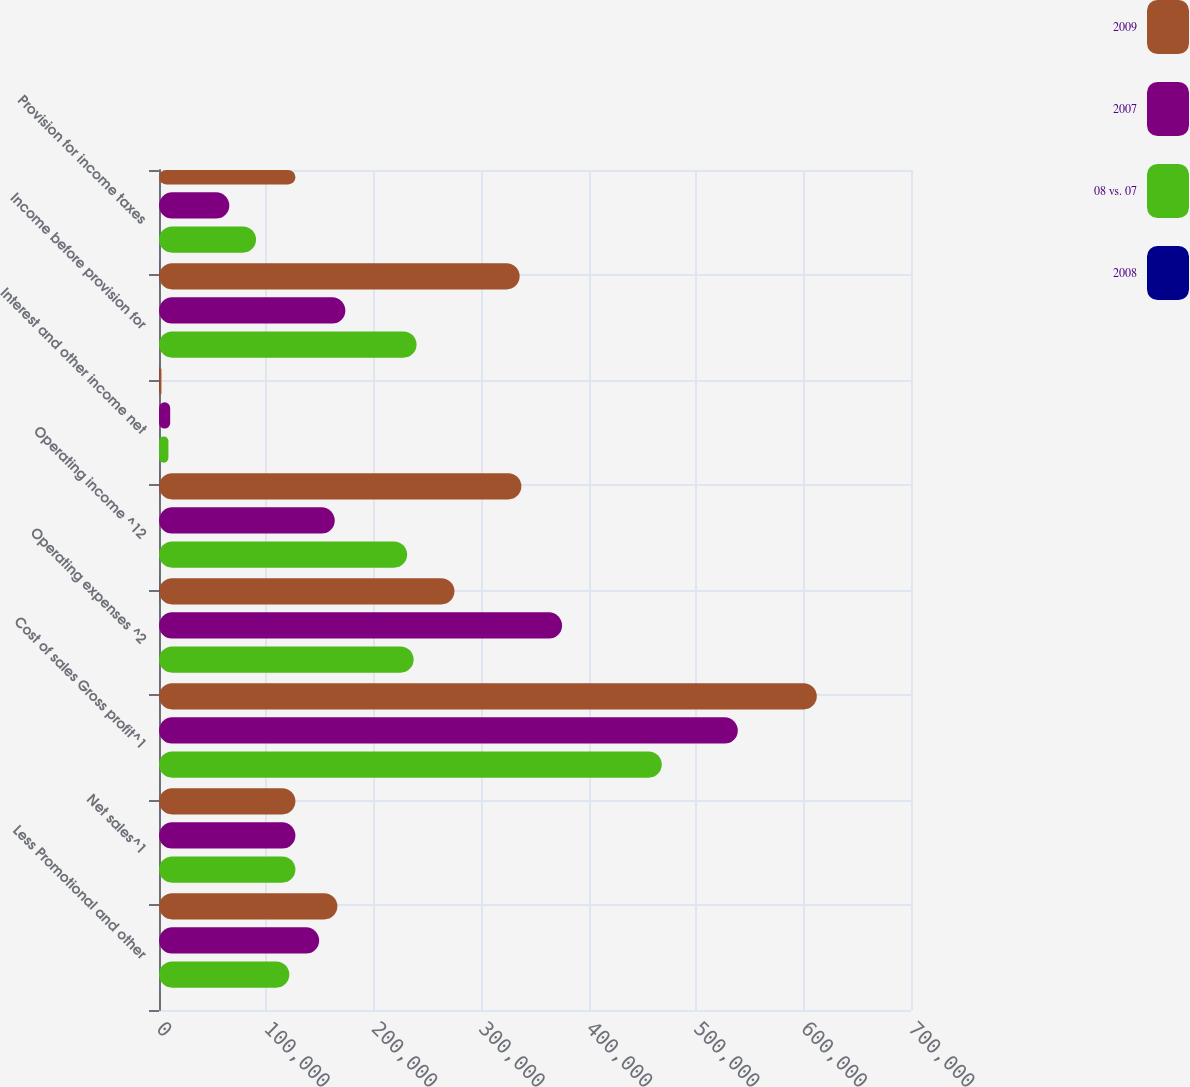Convert chart. <chart><loc_0><loc_0><loc_500><loc_500><stacked_bar_chart><ecel><fcel>Less Promotional and other<fcel>Net sales^1<fcel>Cost of sales Gross profit^1<fcel>Operating expenses ^2<fcel>Operating income ^12<fcel>Interest and other income net<fcel>Income before provision for<fcel>Provision for income taxes<nl><fcel>2009<fcel>166036<fcel>126979<fcel>612316<fcel>275007<fcel>337309<fcel>2273<fcel>335695<fcel>126979<nl><fcel>2007<fcel>149096<fcel>126979<fcel>538794<fcel>375203<fcel>163591<fcel>10413<fcel>173477<fcel>65445<nl><fcel>08 vs. 07<fcel>121330<fcel>126979<fcel>468013<fcel>237027<fcel>230986<fcel>8770<fcel>239756<fcel>90350<nl><fcel>2008<fcel>11.4<fcel>10.6<fcel>13.6<fcel>26.7<fcel>106.2<fcel>78.2<fcel>93.5<fcel>94<nl></chart> 